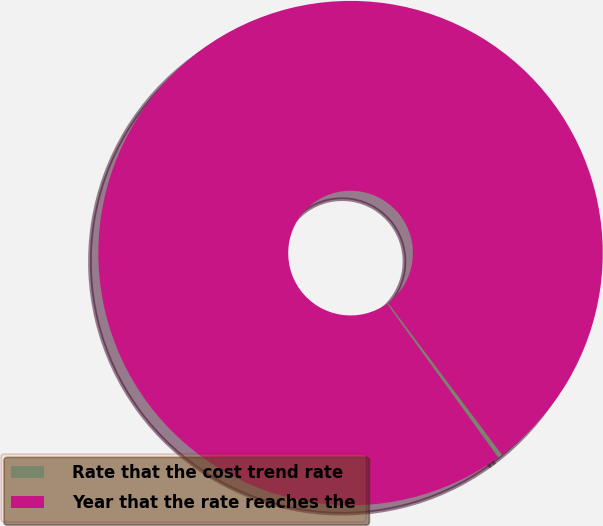Convert chart. <chart><loc_0><loc_0><loc_500><loc_500><pie_chart><fcel>Rate that the cost trend rate<fcel>Year that the rate reaches the<nl><fcel>0.29%<fcel>99.71%<nl></chart> 